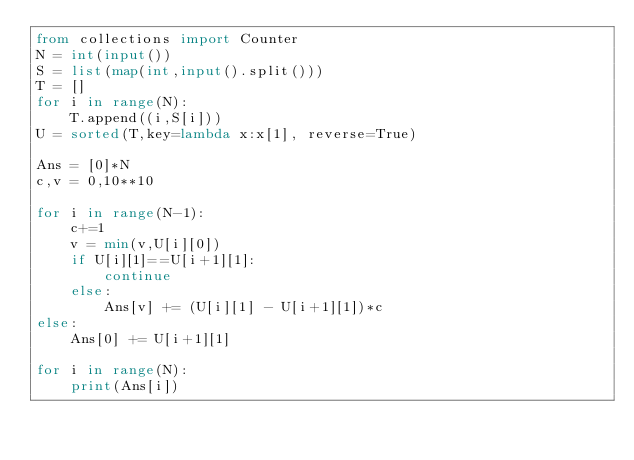<code> <loc_0><loc_0><loc_500><loc_500><_Python_>from collections import Counter
N = int(input())
S = list(map(int,input().split()))
T = []
for i in range(N):
    T.append((i,S[i]))
U = sorted(T,key=lambda x:x[1], reverse=True)

Ans = [0]*N
c,v = 0,10**10

for i in range(N-1):
    c+=1
    v = min(v,U[i][0])
    if U[i][1]==U[i+1][1]:
        continue
    else:
        Ans[v] += (U[i][1] - U[i+1][1])*c
else:
    Ans[0] += U[i+1][1]

for i in range(N):
    print(Ans[i])</code> 